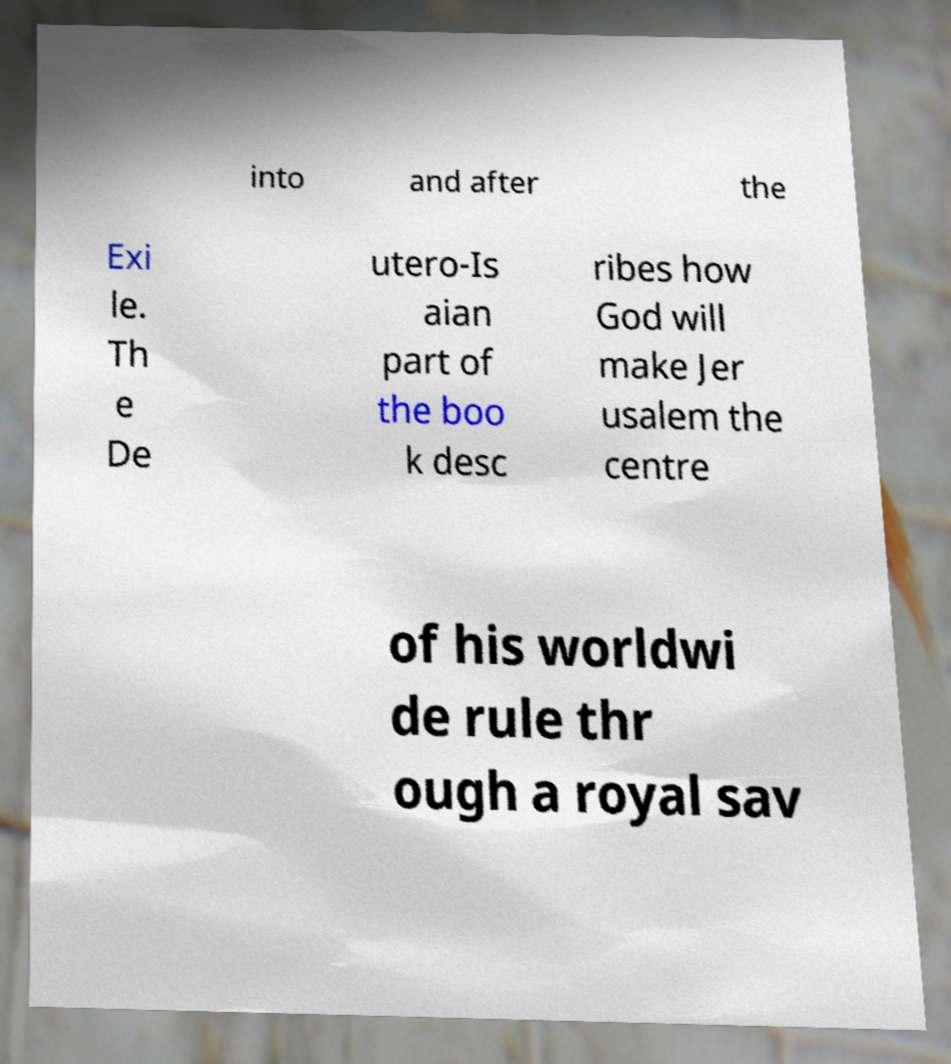For documentation purposes, I need the text within this image transcribed. Could you provide that? into and after the Exi le. Th e De utero-Is aian part of the boo k desc ribes how God will make Jer usalem the centre of his worldwi de rule thr ough a royal sav 